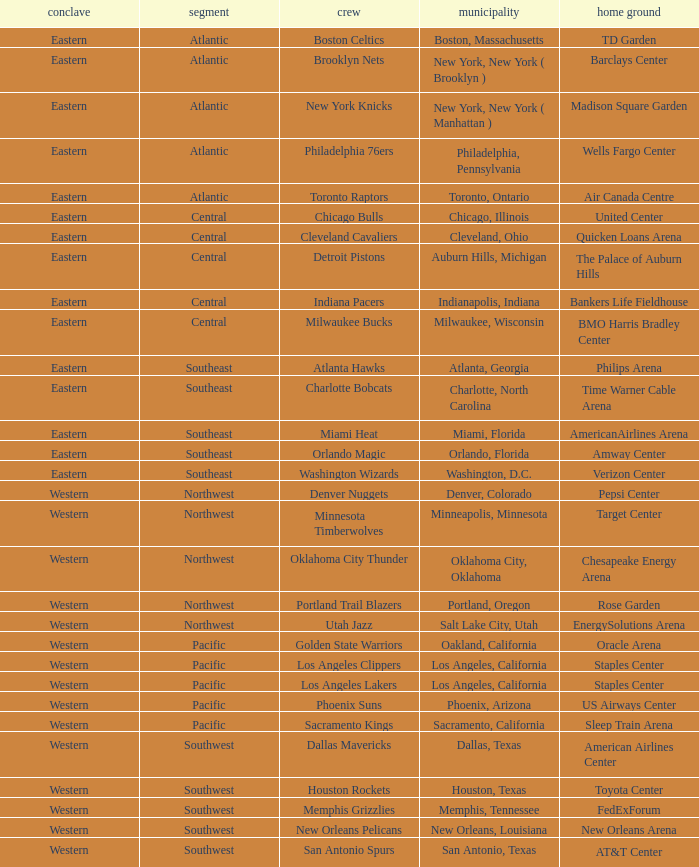Parse the full table. {'header': ['conclave', 'segment', 'crew', 'municipality', 'home ground'], 'rows': [['Eastern', 'Atlantic', 'Boston Celtics', 'Boston, Massachusetts', 'TD Garden'], ['Eastern', 'Atlantic', 'Brooklyn Nets', 'New York, New York ( Brooklyn )', 'Barclays Center'], ['Eastern', 'Atlantic', 'New York Knicks', 'New York, New York ( Manhattan )', 'Madison Square Garden'], ['Eastern', 'Atlantic', 'Philadelphia 76ers', 'Philadelphia, Pennsylvania', 'Wells Fargo Center'], ['Eastern', 'Atlantic', 'Toronto Raptors', 'Toronto, Ontario', 'Air Canada Centre'], ['Eastern', 'Central', 'Chicago Bulls', 'Chicago, Illinois', 'United Center'], ['Eastern', 'Central', 'Cleveland Cavaliers', 'Cleveland, Ohio', 'Quicken Loans Arena'], ['Eastern', 'Central', 'Detroit Pistons', 'Auburn Hills, Michigan', 'The Palace of Auburn Hills'], ['Eastern', 'Central', 'Indiana Pacers', 'Indianapolis, Indiana', 'Bankers Life Fieldhouse'], ['Eastern', 'Central', 'Milwaukee Bucks', 'Milwaukee, Wisconsin', 'BMO Harris Bradley Center'], ['Eastern', 'Southeast', 'Atlanta Hawks', 'Atlanta, Georgia', 'Philips Arena'], ['Eastern', 'Southeast', 'Charlotte Bobcats', 'Charlotte, North Carolina', 'Time Warner Cable Arena'], ['Eastern', 'Southeast', 'Miami Heat', 'Miami, Florida', 'AmericanAirlines Arena'], ['Eastern', 'Southeast', 'Orlando Magic', 'Orlando, Florida', 'Amway Center'], ['Eastern', 'Southeast', 'Washington Wizards', 'Washington, D.C.', 'Verizon Center'], ['Western', 'Northwest', 'Denver Nuggets', 'Denver, Colorado', 'Pepsi Center'], ['Western', 'Northwest', 'Minnesota Timberwolves', 'Minneapolis, Minnesota', 'Target Center'], ['Western', 'Northwest', 'Oklahoma City Thunder', 'Oklahoma City, Oklahoma', 'Chesapeake Energy Arena'], ['Western', 'Northwest', 'Portland Trail Blazers', 'Portland, Oregon', 'Rose Garden'], ['Western', 'Northwest', 'Utah Jazz', 'Salt Lake City, Utah', 'EnergySolutions Arena'], ['Western', 'Pacific', 'Golden State Warriors', 'Oakland, California', 'Oracle Arena'], ['Western', 'Pacific', 'Los Angeles Clippers', 'Los Angeles, California', 'Staples Center'], ['Western', 'Pacific', 'Los Angeles Lakers', 'Los Angeles, California', 'Staples Center'], ['Western', 'Pacific', 'Phoenix Suns', 'Phoenix, Arizona', 'US Airways Center'], ['Western', 'Pacific', 'Sacramento Kings', 'Sacramento, California', 'Sleep Train Arena'], ['Western', 'Southwest', 'Dallas Mavericks', 'Dallas, Texas', 'American Airlines Center'], ['Western', 'Southwest', 'Houston Rockets', 'Houston, Texas', 'Toyota Center'], ['Western', 'Southwest', 'Memphis Grizzlies', 'Memphis, Tennessee', 'FedExForum'], ['Western', 'Southwest', 'New Orleans Pelicans', 'New Orleans, Louisiana', 'New Orleans Arena'], ['Western', 'Southwest', 'San Antonio Spurs', 'San Antonio, Texas', 'AT&T Center']]} Which division do the Toronto Raptors belong in? Atlantic. 